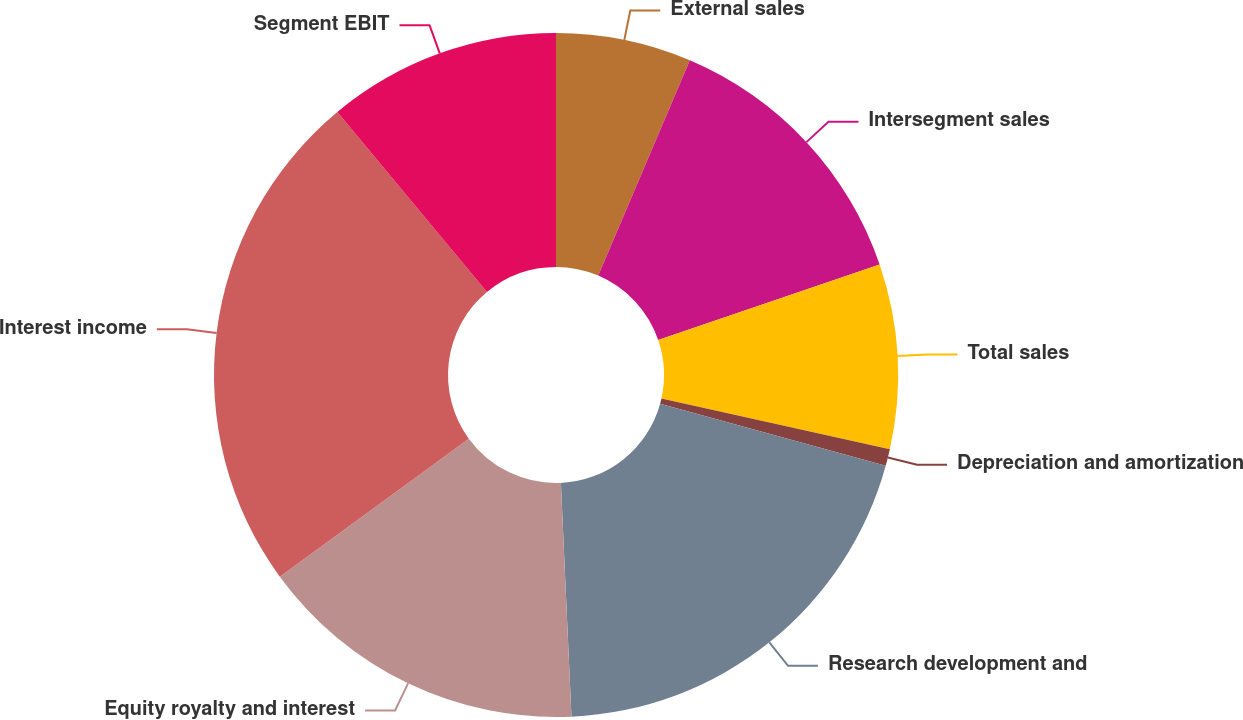Convert chart. <chart><loc_0><loc_0><loc_500><loc_500><pie_chart><fcel>External sales<fcel>Intersegment sales<fcel>Total sales<fcel>Depreciation and amortization<fcel>Research development and<fcel>Equity royalty and interest<fcel>Interest income<fcel>Segment EBIT<nl><fcel>6.4%<fcel>13.36%<fcel>8.72%<fcel>0.8%<fcel>20.0%<fcel>15.68%<fcel>24.0%<fcel>11.04%<nl></chart> 